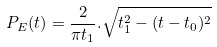Convert formula to latex. <formula><loc_0><loc_0><loc_500><loc_500>P _ { E } ( t ) = \frac { 2 } { \pi t _ { 1 } } . \sqrt { t _ { 1 } ^ { 2 } - ( t - t _ { 0 } ) ^ { 2 } }</formula> 